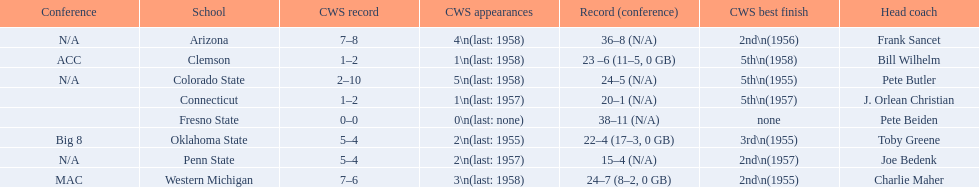Can you name the schools that had the worst rankings in the cws best finish? Clemson, Colorado State, Connecticut. 